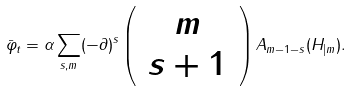Convert formula to latex. <formula><loc_0><loc_0><loc_500><loc_500>\bar { \varphi } _ { t } = \alpha \sum _ { s , m } ( - \partial ) ^ { s } \left ( \, \begin{array} { c } m \\ s + 1 \end{array} \, \right ) A _ { m - 1 - s } ( H _ { | m } ) .</formula> 